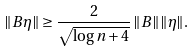<formula> <loc_0><loc_0><loc_500><loc_500>\| B \eta \| \geq \frac { 2 } { \sqrt { \log n + 4 } } \, \| B \| \| \eta \| .</formula> 